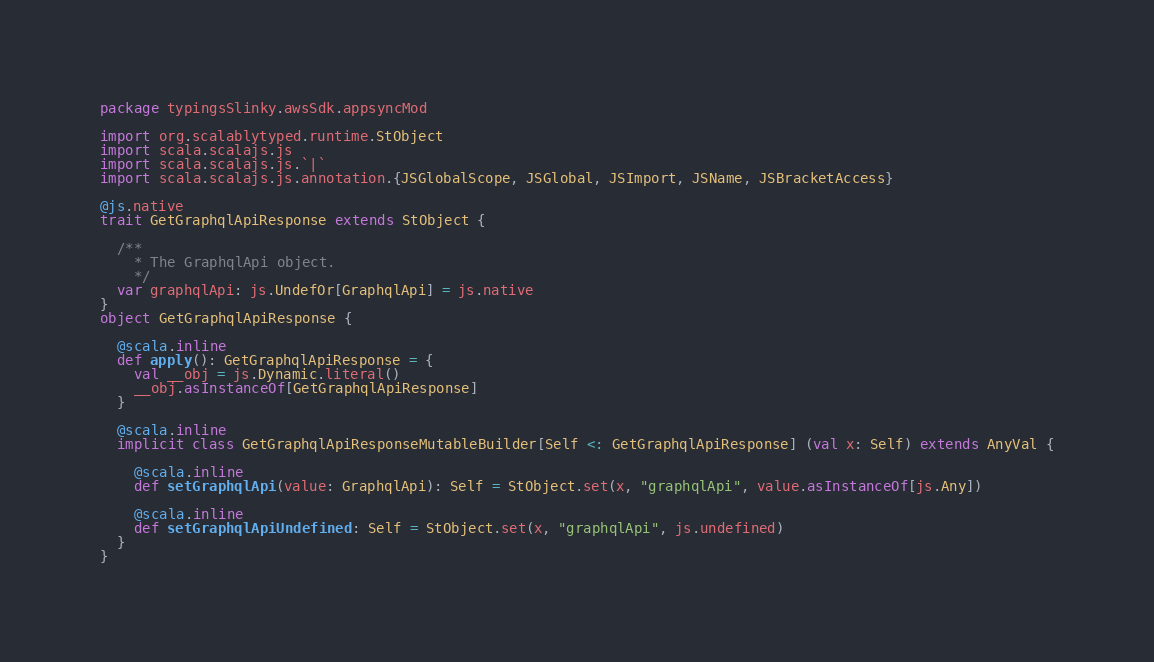<code> <loc_0><loc_0><loc_500><loc_500><_Scala_>package typingsSlinky.awsSdk.appsyncMod

import org.scalablytyped.runtime.StObject
import scala.scalajs.js
import scala.scalajs.js.`|`
import scala.scalajs.js.annotation.{JSGlobalScope, JSGlobal, JSImport, JSName, JSBracketAccess}

@js.native
trait GetGraphqlApiResponse extends StObject {
  
  /**
    * The GraphqlApi object.
    */
  var graphqlApi: js.UndefOr[GraphqlApi] = js.native
}
object GetGraphqlApiResponse {
  
  @scala.inline
  def apply(): GetGraphqlApiResponse = {
    val __obj = js.Dynamic.literal()
    __obj.asInstanceOf[GetGraphqlApiResponse]
  }
  
  @scala.inline
  implicit class GetGraphqlApiResponseMutableBuilder[Self <: GetGraphqlApiResponse] (val x: Self) extends AnyVal {
    
    @scala.inline
    def setGraphqlApi(value: GraphqlApi): Self = StObject.set(x, "graphqlApi", value.asInstanceOf[js.Any])
    
    @scala.inline
    def setGraphqlApiUndefined: Self = StObject.set(x, "graphqlApi", js.undefined)
  }
}
</code> 